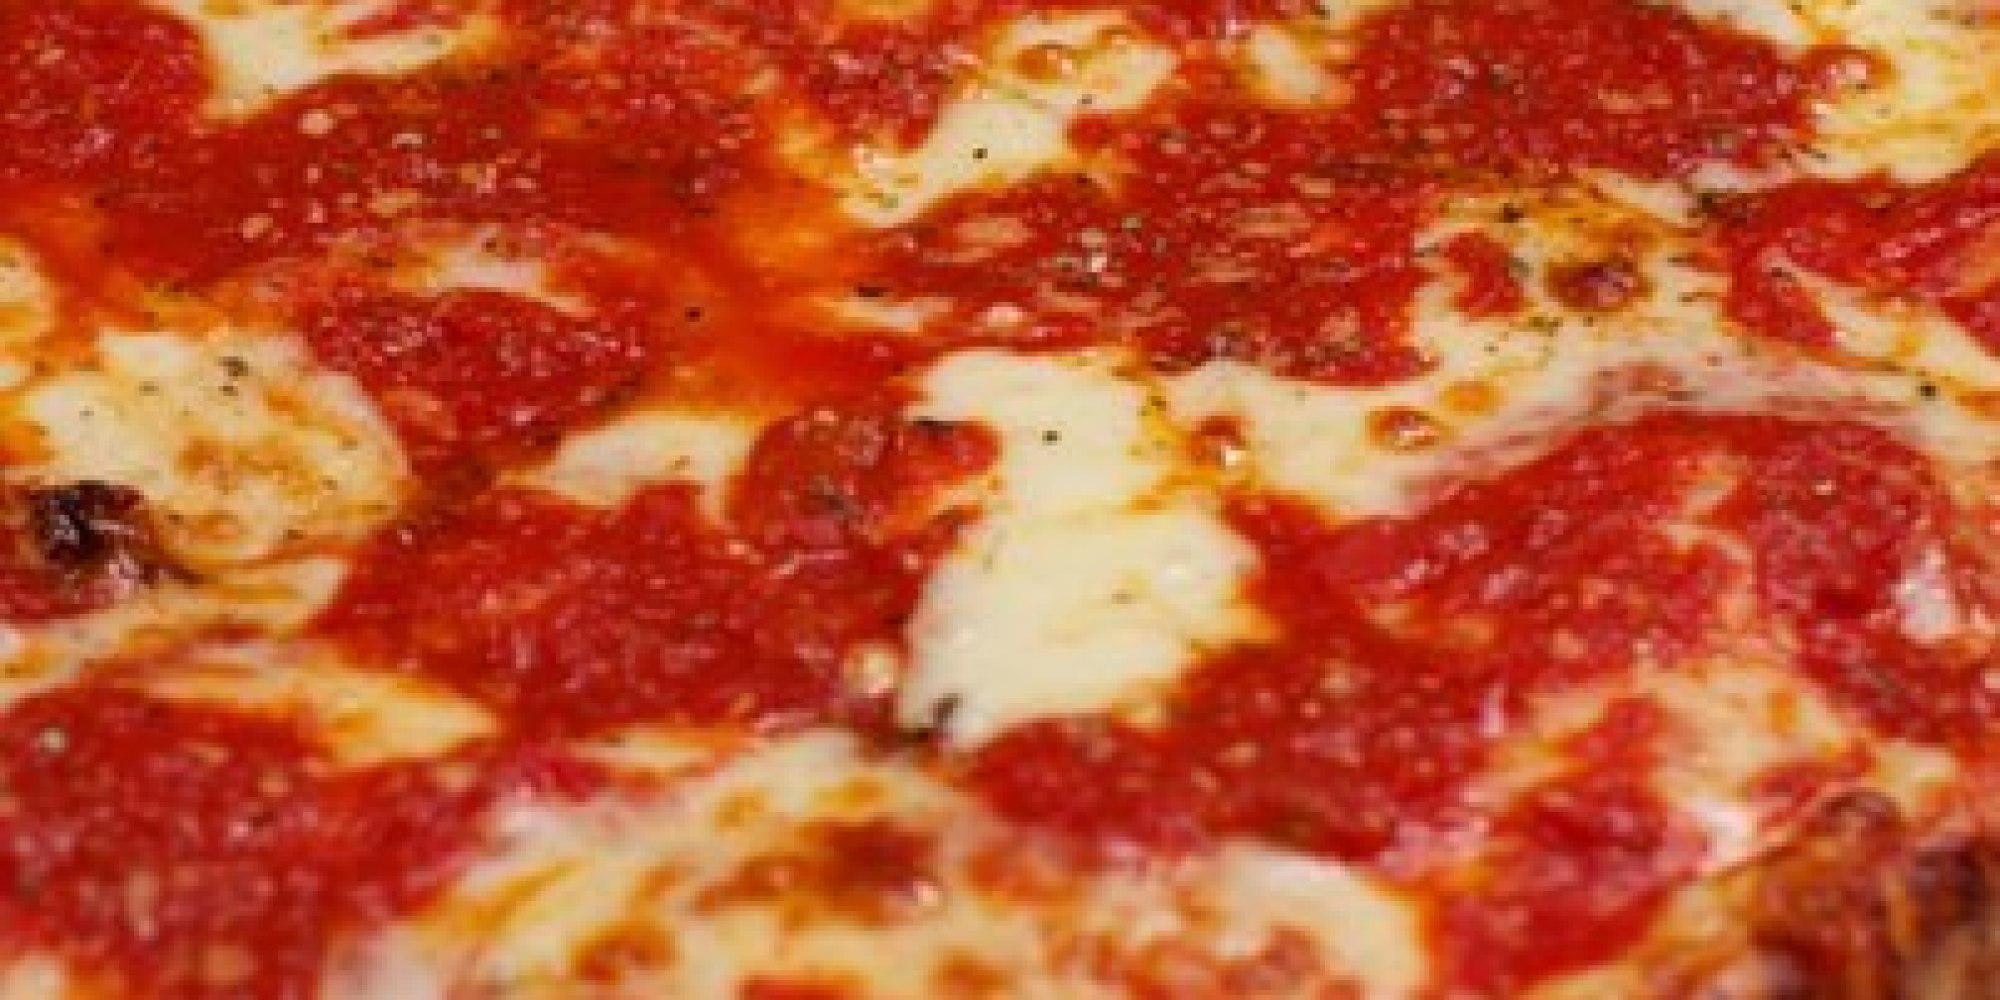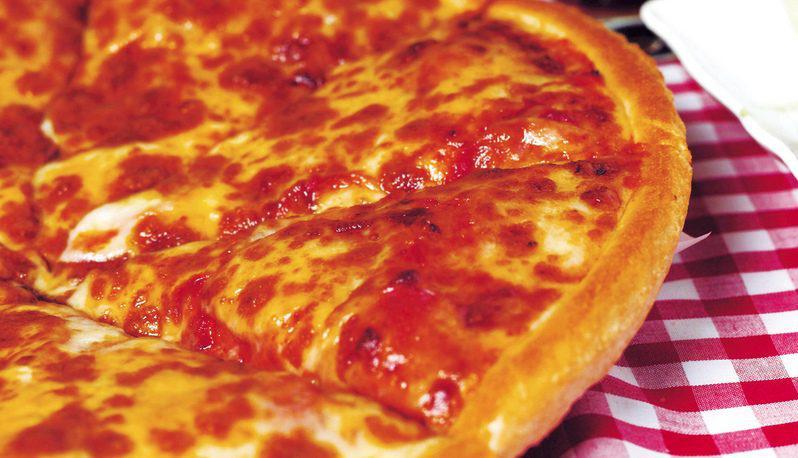The first image is the image on the left, the second image is the image on the right. Analyze the images presented: Is the assertion "There are pepperoni slices on top of the cheese layer on the pizza." valid? Answer yes or no. No. The first image is the image on the left, the second image is the image on the right. Examine the images to the left and right. Is the description "None of the pizza shown has pepperoni on it." accurate? Answer yes or no. Yes. 